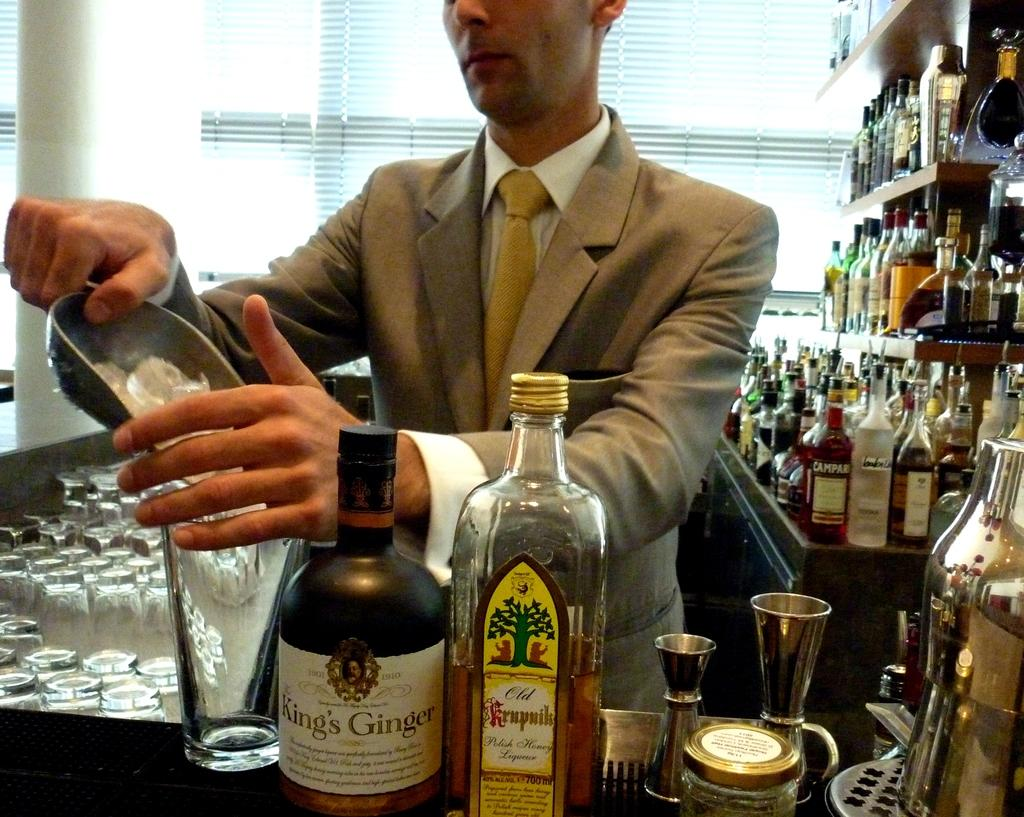<image>
Provide a brief description of the given image. A man is pouring ice into a glass at a bar by a bottle of King's Ginger. 